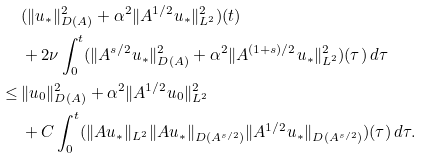Convert formula to latex. <formula><loc_0><loc_0><loc_500><loc_500>& \, ( \| u _ { * } \| _ { D ( A ) } ^ { 2 } + \alpha ^ { 2 } \| A ^ { 1 / 2 } u _ { * } \| _ { L ^ { 2 } } ^ { 2 } ) ( t ) \\ & \, + 2 \nu \int _ { 0 } ^ { t } ( \| A ^ { s / 2 } u _ { * } \| ^ { 2 } _ { D ( A ) } + \alpha ^ { 2 } \| A ^ { ( 1 + s ) / 2 } u _ { * } \| ^ { 2 } _ { L ^ { 2 } } ) ( \tau ) \, d \tau \\ \leq & \, \| u _ { 0 } \| _ { D ( A ) } ^ { 2 } + \alpha ^ { 2 } \| A ^ { 1 / 2 } u _ { 0 } \| _ { L ^ { 2 } } ^ { 2 } \\ & \, + C \int _ { 0 } ^ { t } ( \| A u _ { * } \| _ { L ^ { 2 } } \| A u _ { * } \| _ { D ( A ^ { s / 2 } ) } \| A ^ { 1 / 2 } u _ { * } \| _ { D ( A ^ { s / 2 } ) } ) ( \tau ) \, d \tau .</formula> 